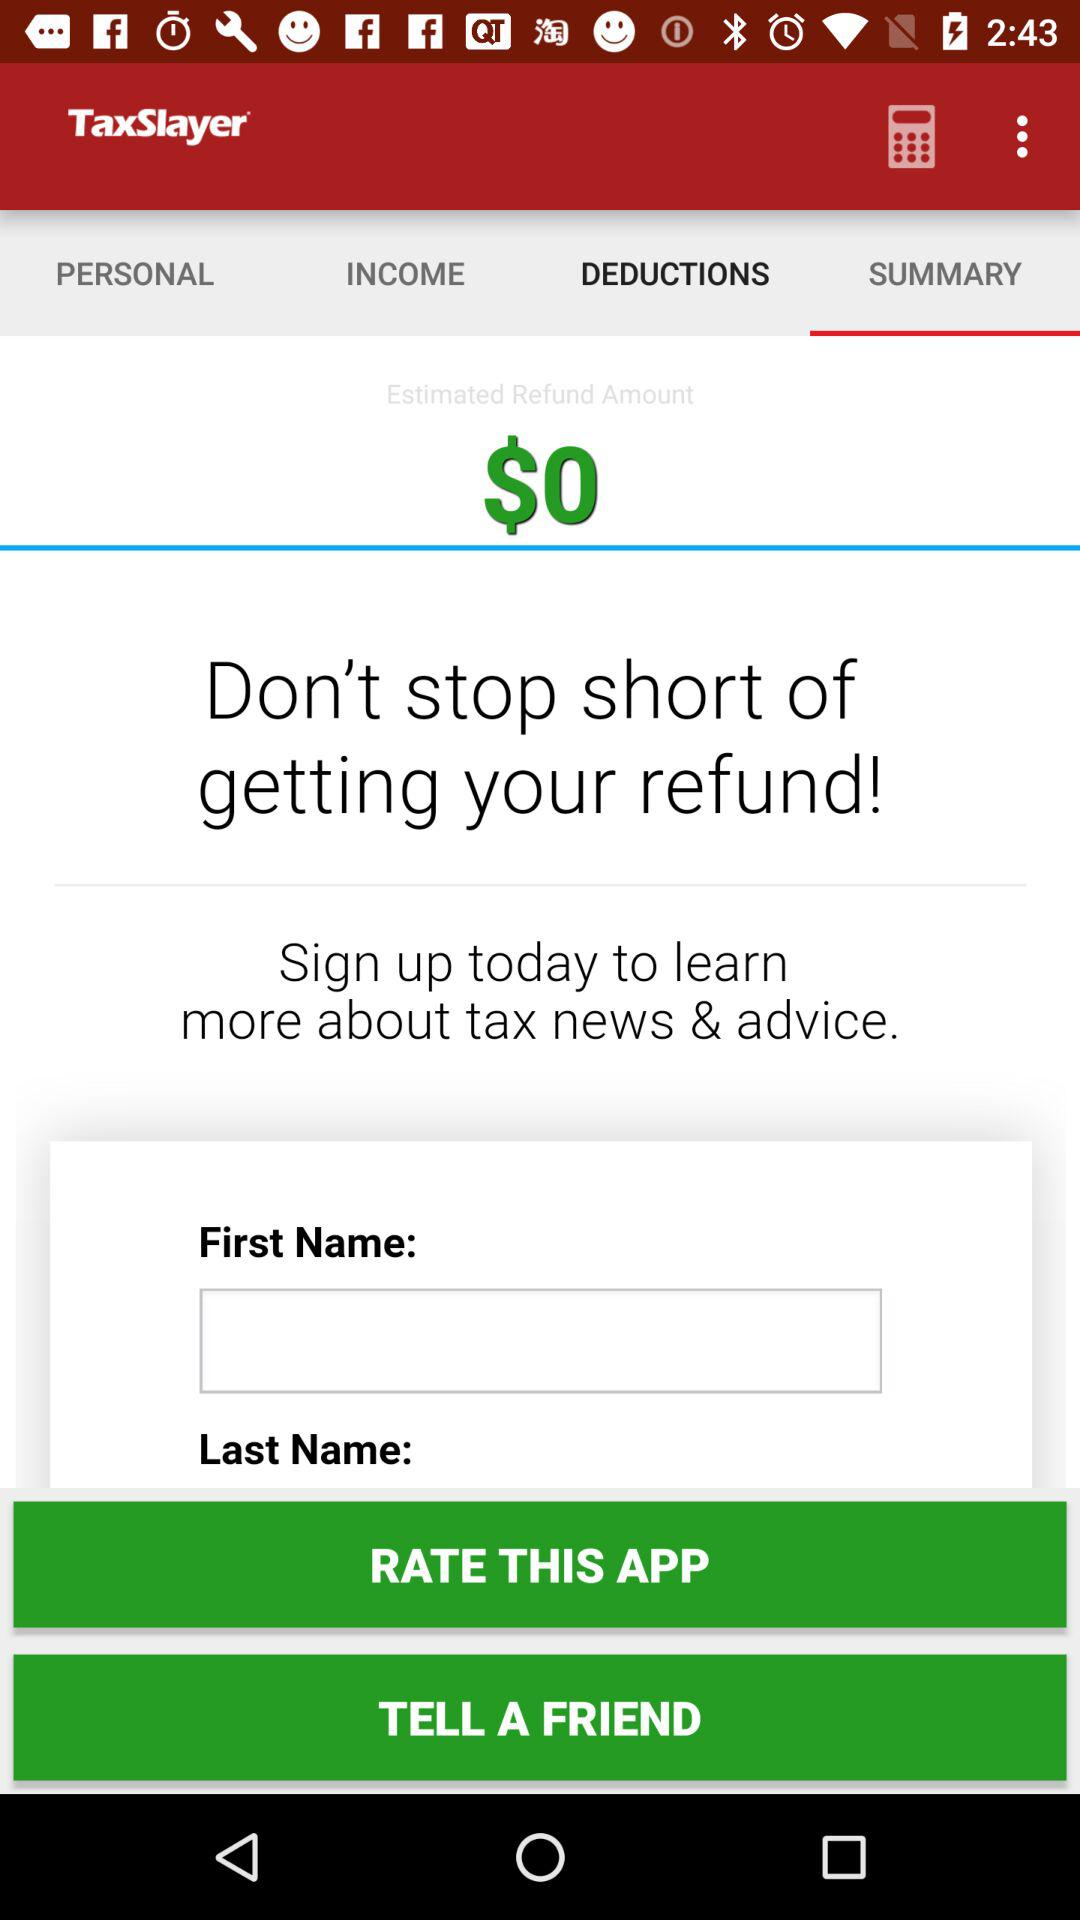How much is the income?
When the provided information is insufficient, respond with <no answer>. <no answer> 